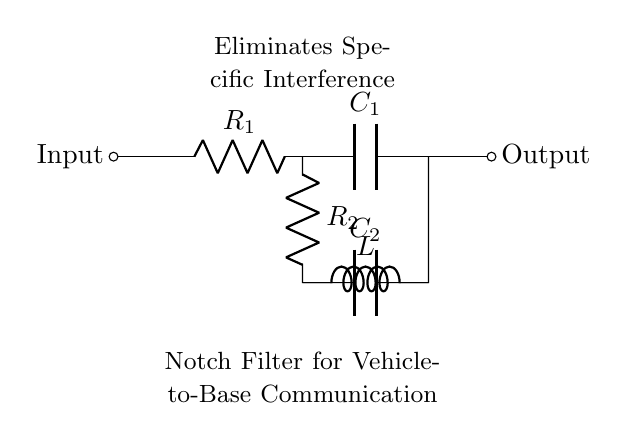What is the purpose of this circuit? The purpose is to eliminate specific interference in vehicle-to-base communication systems, as noted in the circuit diagram.
Answer: Eliminate interference What components are used in this notch filter? The components are two resistors, two capacitors, and one inductor, as identified by the labels in the circuit.
Answer: Two resistors, two capacitors, one inductor Where is the input and output of the circuit located? The input is located on the left side of the circuit, and the output is on the right side, as indicated by the labels in the diagram.
Answer: Left and right What is the configuration of R1 and C1? R1 is in series with C1, from the input node to the output node of the circuit. They are connected directly in line.
Answer: Series How does the inductor contribute to the notch filter's function? The inductor works with the capacitors to create a resonant circuit, which helps to filter out specific frequency interference from the signal.
Answer: Creates resonant circuit What type of filter is represented by this circuit? This circuit represents a notch filter, which specifically blocks certain frequencies while allowing others to pass through.
Answer: Notch filter What is the relationship between R2 and C2? R2 and C2 are in parallel with each other, providing a different response to the input signal compared to R1 and C1.
Answer: Parallel 